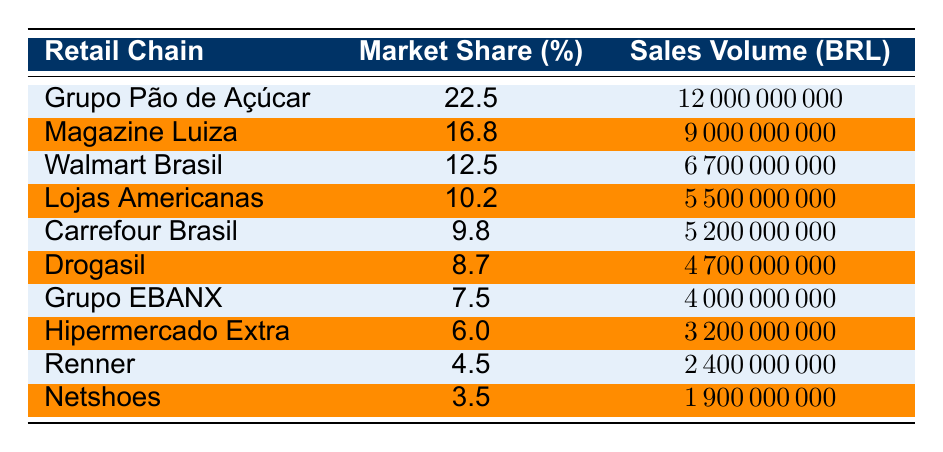What is the market share percentage of Grupo Pão de Açúcar? Grupo Pão de Açúcar's market share percentage can be found directly in the table under the "Market Share (%)" column. The entry for this retail chain shows a percentage of 22.5%.
Answer: 22.5% Which retail chain has the highest sales volume in BRL? To find the highest sales volume, we look at the "Sales Volume (BRL)" column and identify the largest number. Grupo Pão de Açúcar has the highest sales volume at 12,000,000,000 BRL.
Answer: Grupo Pão de Açúcar What is the difference in sales volume between Magazine Luiza and Walmart Brasil? We find the sales volumes for both retail chains: Magazine Luiza at 9,000,000,000 BRL and Walmart Brasil at 6,700,000,000 BRL. The difference is calculated as 9,000,000,000 - 6,700,000,000 = 2,300,000,000 BRL.
Answer: 2,300,000,000 BRL What is the total market share percentage of the top three retail chains? The top three retail chains are Grupo Pão de Açúcar (22.5%), Magazine Luiza (16.8%), and Walmart Brasil (12.5%). We add these percentages: 22.5 + 16.8 + 12.5 = 51.8%.
Answer: 51.8% Is Walmart Brasil's market share higher than 10%? Walmart Brasil has a market share percentage of 12.5%. Checking if this is greater than 10% shows that it indeed is, confirming it's a "yes."
Answer: Yes What retail chain has the lowest market share percentage, and what is that percentage? Reviewing the "Market Share (%)" column, we identify the retail chain with the lowest percentage, which is Netshoes at 3.5%.
Answer: Netshoes, 3.5% What percentage of the total sales volume comes from Drogasil and Grupo EBANX combined? The sales volume for Drogasil is 4,700,000,000 BRL and for Grupo EBANX is 4,000,000,000 BRL. Adding these gives 4,700,000,000 + 4,000,000,000 = 8,700,000,000 BRL. The total sales for all chains is 53,300,000,000 BRL. The percentage is (8,700,000,000 / 53,300,000,000) * 100 = 16.3%.
Answer: 16.3% How many retail chains have a market share percentage less than 10%? Looking at the "Market Share (%)" column, only Hipermercado Extra (6.0%), Renner (4.5%), and Netshoes (3.5%) fall below 10%. This gives us a total of three retail chains.
Answer: 3 What is the average sales volume of the top five retail chains? The sales volumes for the top five are: 12,000,000,000 BRL (Grupo Pão de Açúcar), 9,000,000,000 BRL (Magazine Luiza), 6,700,000,000 BRL (Walmart Brasil), 5,500,000,000 BRL (Lojas Americanas), and 5,200,000,000 BRL (Carrefour Brasil). The sum is 12,000,000,000 + 9,000,000,000 + 6,700,000,000 + 5,500,000,000 + 5,200,000,000 = 38,400,000,000 BRL. The average is 38,400,000,000 / 5 = 7,680,000,000 BRL.
Answer: 7,680,000,000 BRL Which retail chain's market share is closest to 5%? We look through the "Market Share (%)" column to find the closest value to 5%. Grupo EBANX has a market share of 7.5%, which is the nearest to 5% among all listed chains.
Answer: Grupo EBANX, 7.5% 